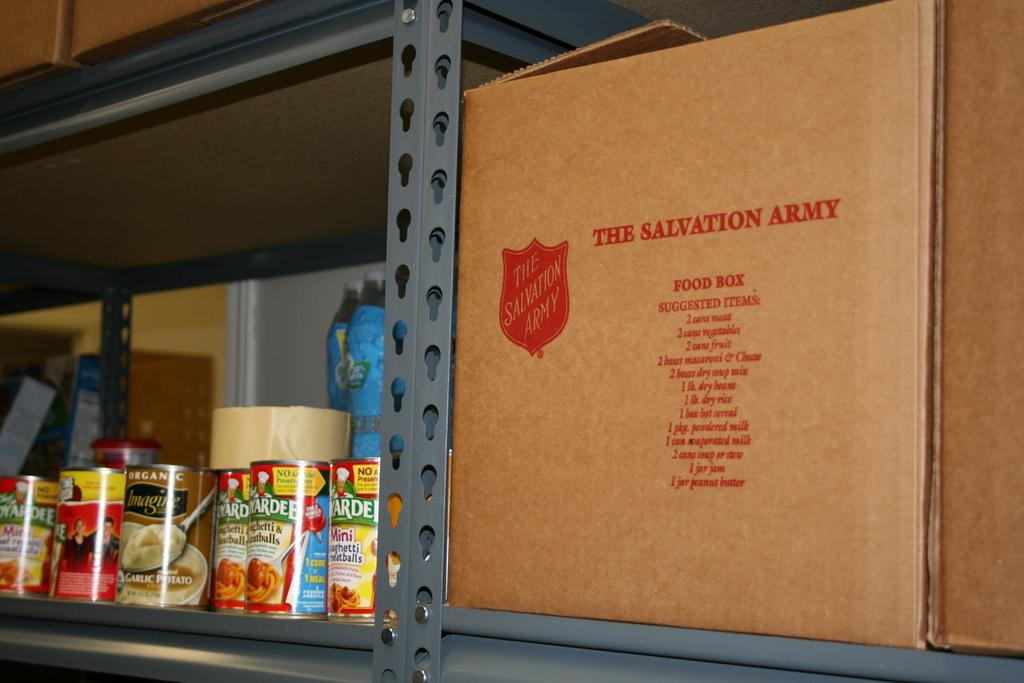<image>
Present a compact description of the photo's key features. Cans of food next to a Salvation Army cardboard box 